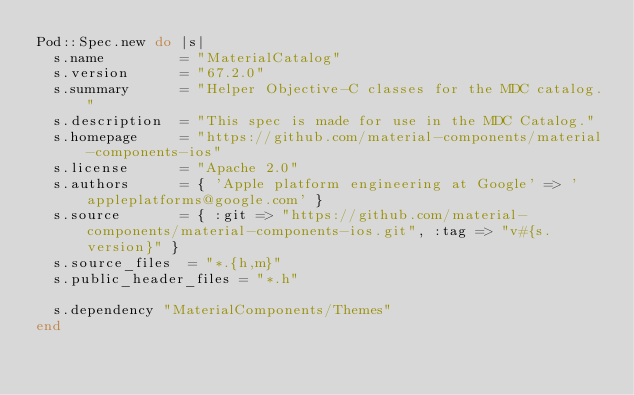Convert code to text. <code><loc_0><loc_0><loc_500><loc_500><_Ruby_>Pod::Spec.new do |s|
  s.name         = "MaterialCatalog"
  s.version      = "67.2.0"
  s.summary      = "Helper Objective-C classes for the MDC catalog."
  s.description  = "This spec is made for use in the MDC Catalog."
  s.homepage     = "https://github.com/material-components/material-components-ios"
  s.license      = "Apache 2.0"
  s.authors      = { 'Apple platform engineering at Google' => 'appleplatforms@google.com' }
  s.source       = { :git => "https://github.com/material-components/material-components-ios.git", :tag => "v#{s.version}" }
  s.source_files  = "*.{h,m}"
  s.public_header_files = "*.h"

  s.dependency "MaterialComponents/Themes"
end
</code> 